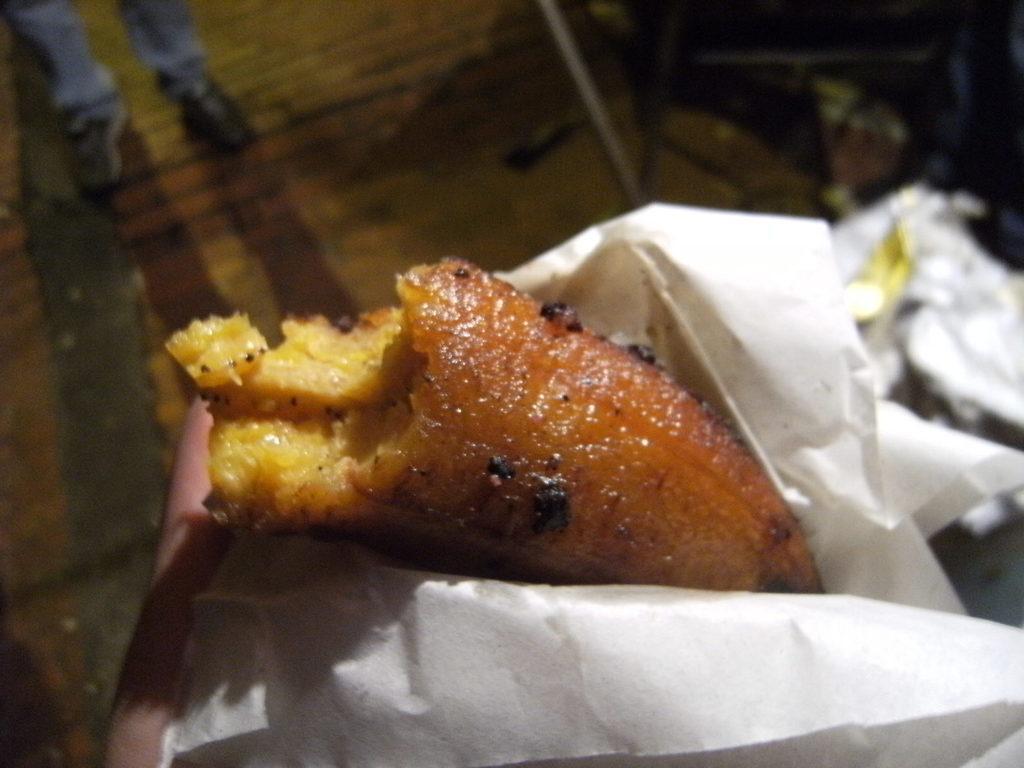Can you describe this image briefly? Here I can see a person's hand holding a food item which is covered with a paper. The background is blurred. 